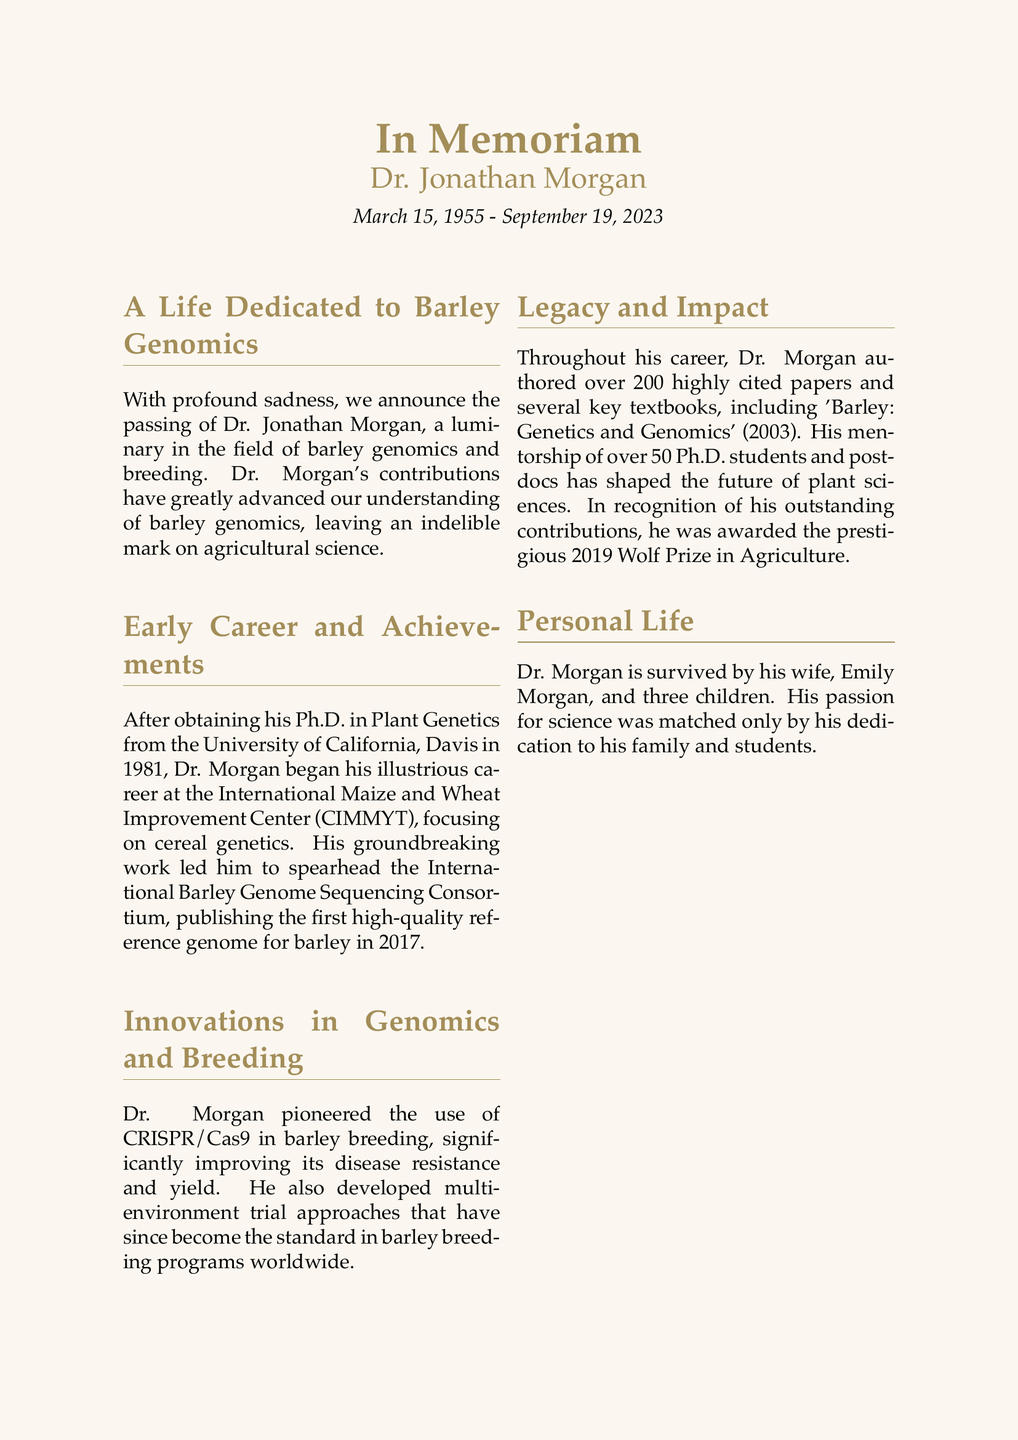What is the full name of the geneticist? The document states the full name of the geneticist as Dr. Jonathan Morgan.
Answer: Dr. Jonathan Morgan What is the date of death? The document provides the date of death as September 19, 2023.
Answer: September 19, 2023 How many Ph.D. students did Dr. Morgan mentor? The document mentions that Dr. Morgan mentored over 50 Ph.D. students and postdocs.
Answer: over 50 What prestigious award did Dr. Morgan receive in 2019? The document states that Dr. Morgan was awarded the Wolf Prize in Agriculture.
Answer: Wolf Prize in Agriculture What technique did Dr. Morgan pioneer in barley breeding? The document indicates Dr. Morgan pioneered the use of CRISPR/Cas9 in barley breeding.
Answer: CRISPR/Cas9 What was the title of the key textbook authored by Dr. Morgan? The document states the title of the key textbook as 'Barley: Genetics and Genomics' (2003).
Answer: 'Barley: Genetics and Genomics' (2003) Who made a statement about Dr. Morgan’s transformation of barley genetics? The document includes a statement from Dr. Sarah Thompson, a longtime colleague.
Answer: Dr. Sarah Thompson What institution did Dr. Morgan begin his career at? The document mentions that Dr. Morgan started his career at CIMMYT.
Answer: CIMMYT 